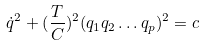Convert formula to latex. <formula><loc_0><loc_0><loc_500><loc_500>\dot { q } ^ { 2 } + ( \frac { T } { C } ) ^ { 2 } ( q _ { 1 } q _ { 2 } \dots q _ { p } ) ^ { 2 } = c</formula> 